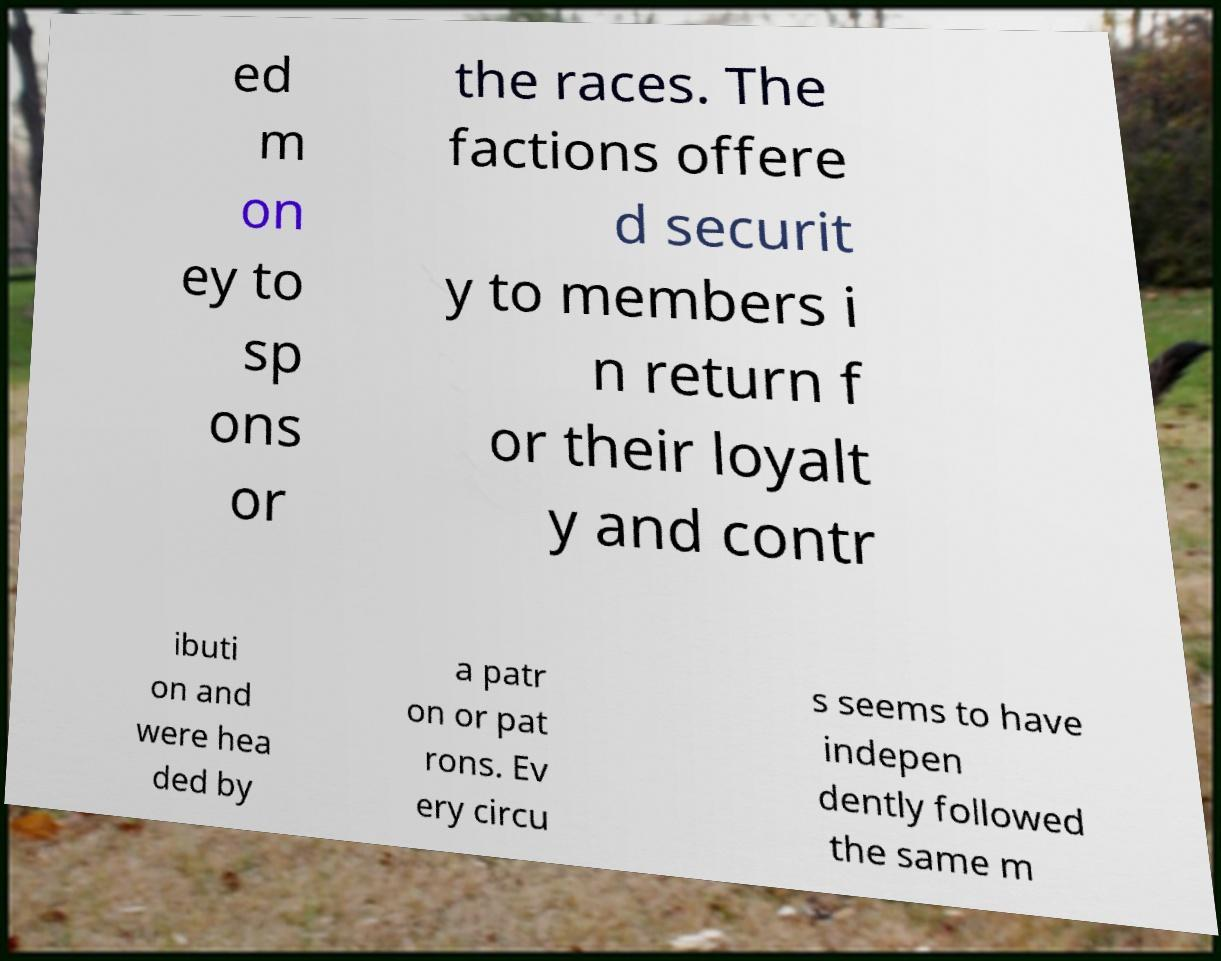Please read and relay the text visible in this image. What does it say? ed m on ey to sp ons or the races. The factions offere d securit y to members i n return f or their loyalt y and contr ibuti on and were hea ded by a patr on or pat rons. Ev ery circu s seems to have indepen dently followed the same m 